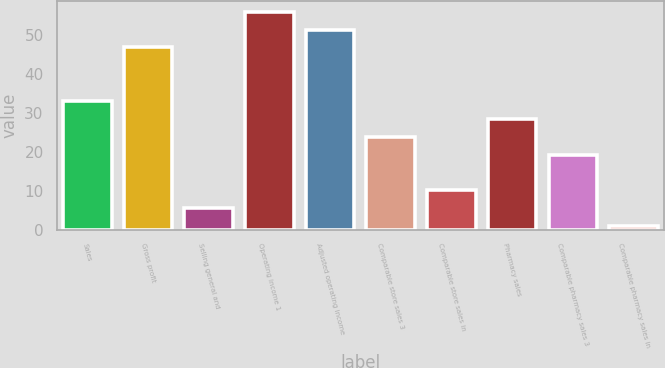Convert chart to OTSL. <chart><loc_0><loc_0><loc_500><loc_500><bar_chart><fcel>Sales<fcel>Gross profit<fcel>Selling general and<fcel>Operating income 1<fcel>Adjusted operating income<fcel>Comparable store sales 3<fcel>Comparable store sales in<fcel>Pharmacy sales<fcel>Comparable pharmacy sales 3<fcel>Comparable pharmacy sales in<nl><fcel>33.03<fcel>46.8<fcel>5.49<fcel>55.98<fcel>51.39<fcel>23.85<fcel>10.08<fcel>28.44<fcel>19.26<fcel>0.9<nl></chart> 